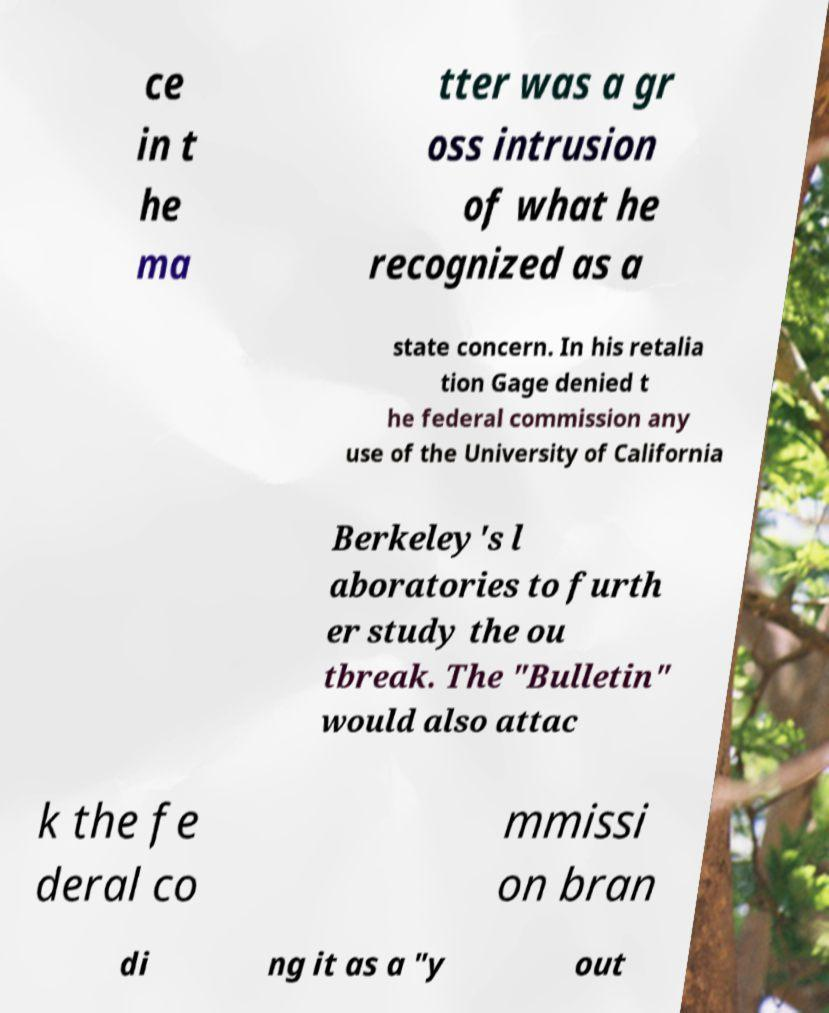What messages or text are displayed in this image? I need them in a readable, typed format. ce in t he ma tter was a gr oss intrusion of what he recognized as a state concern. In his retalia tion Gage denied t he federal commission any use of the University of California Berkeley's l aboratories to furth er study the ou tbreak. The "Bulletin" would also attac k the fe deral co mmissi on bran di ng it as a "y out 